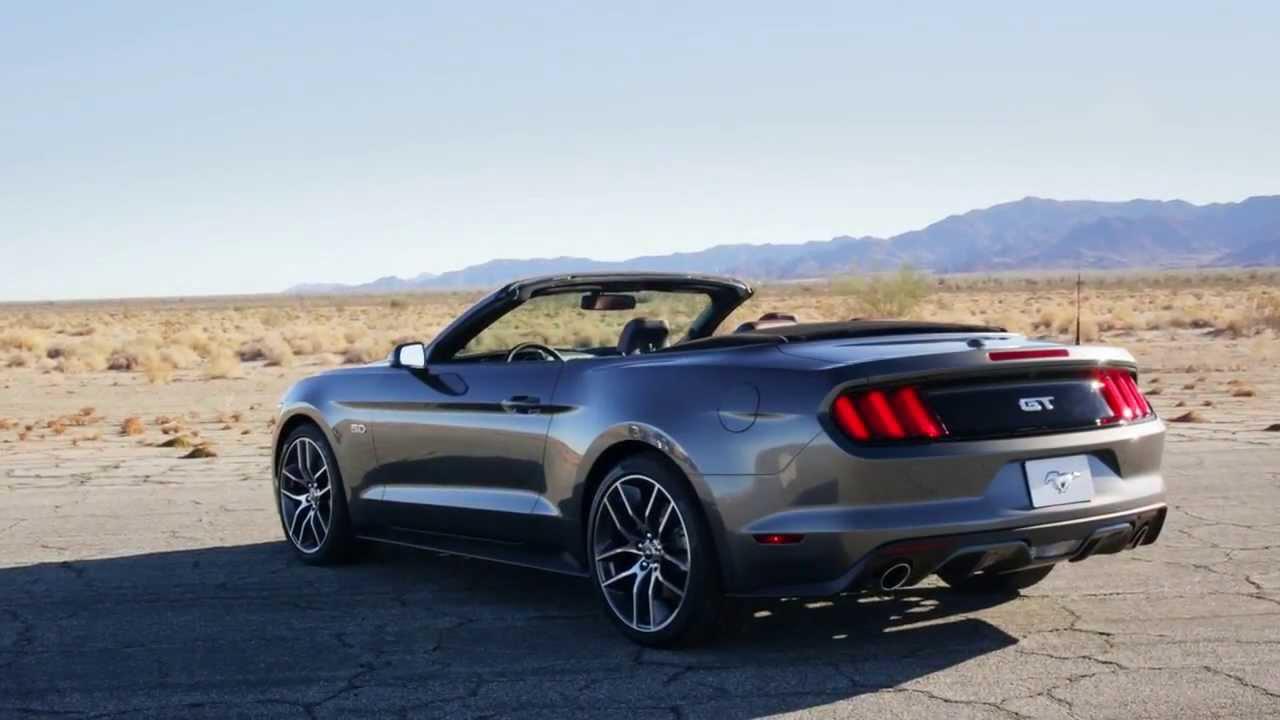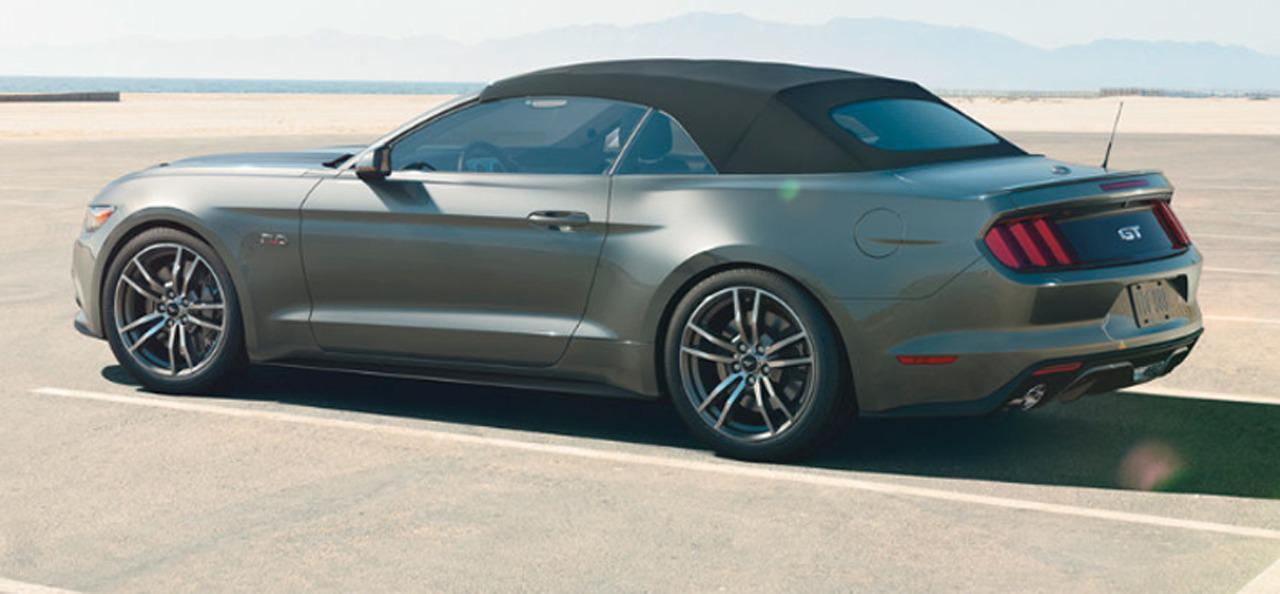The first image is the image on the left, the second image is the image on the right. For the images shown, is this caption "You can't actually see any of the brakes light areas." true? Answer yes or no. No. The first image is the image on the left, the second image is the image on the right. For the images displayed, is the sentence "One of the convertibles doesn't have the top removed." factually correct? Answer yes or no. Yes. 